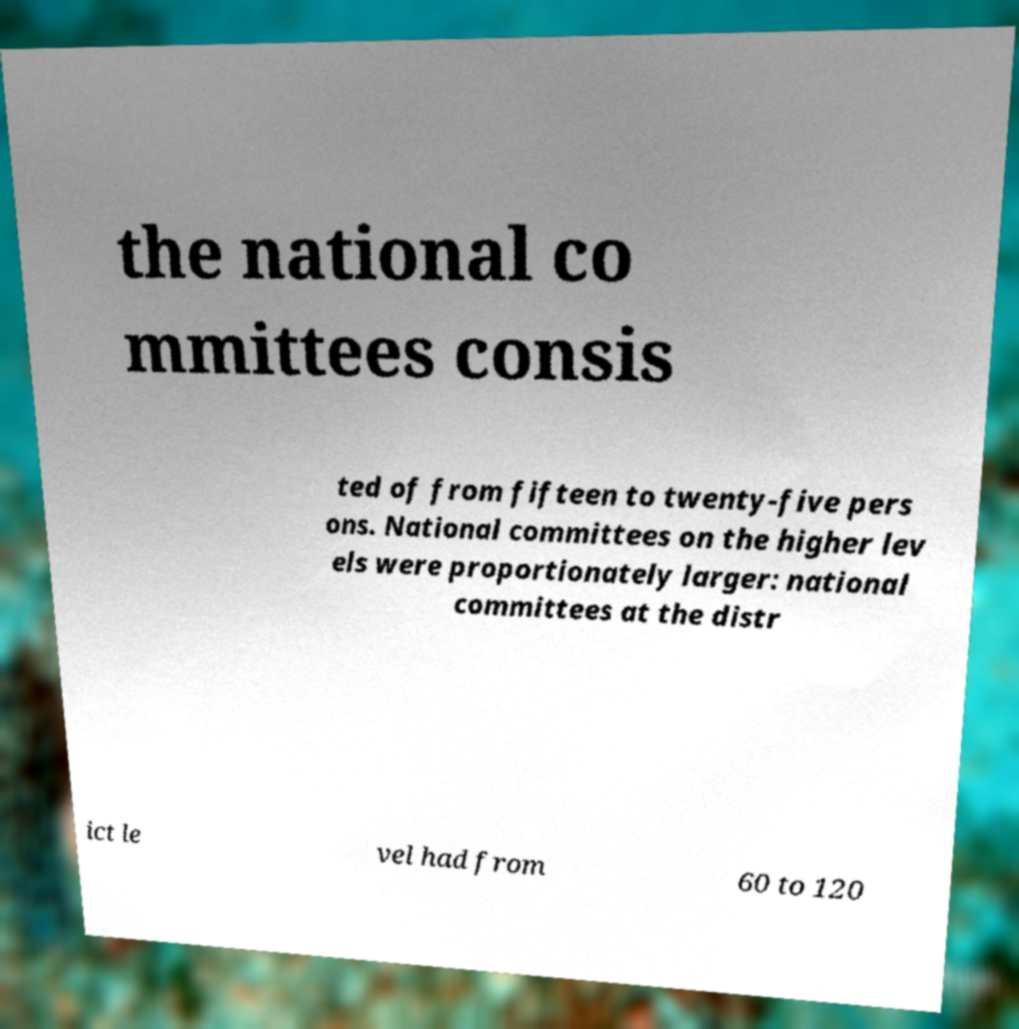Can you accurately transcribe the text from the provided image for me? the national co mmittees consis ted of from fifteen to twenty-five pers ons. National committees on the higher lev els were proportionately larger: national committees at the distr ict le vel had from 60 to 120 